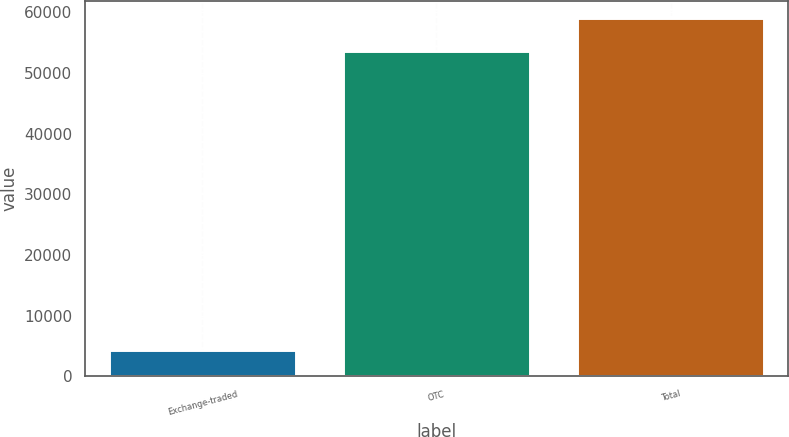Convert chart. <chart><loc_0><loc_0><loc_500><loc_500><bar_chart><fcel>Exchange-traded<fcel>OTC<fcel>Total<nl><fcel>4277<fcel>53602<fcel>58962.2<nl></chart> 